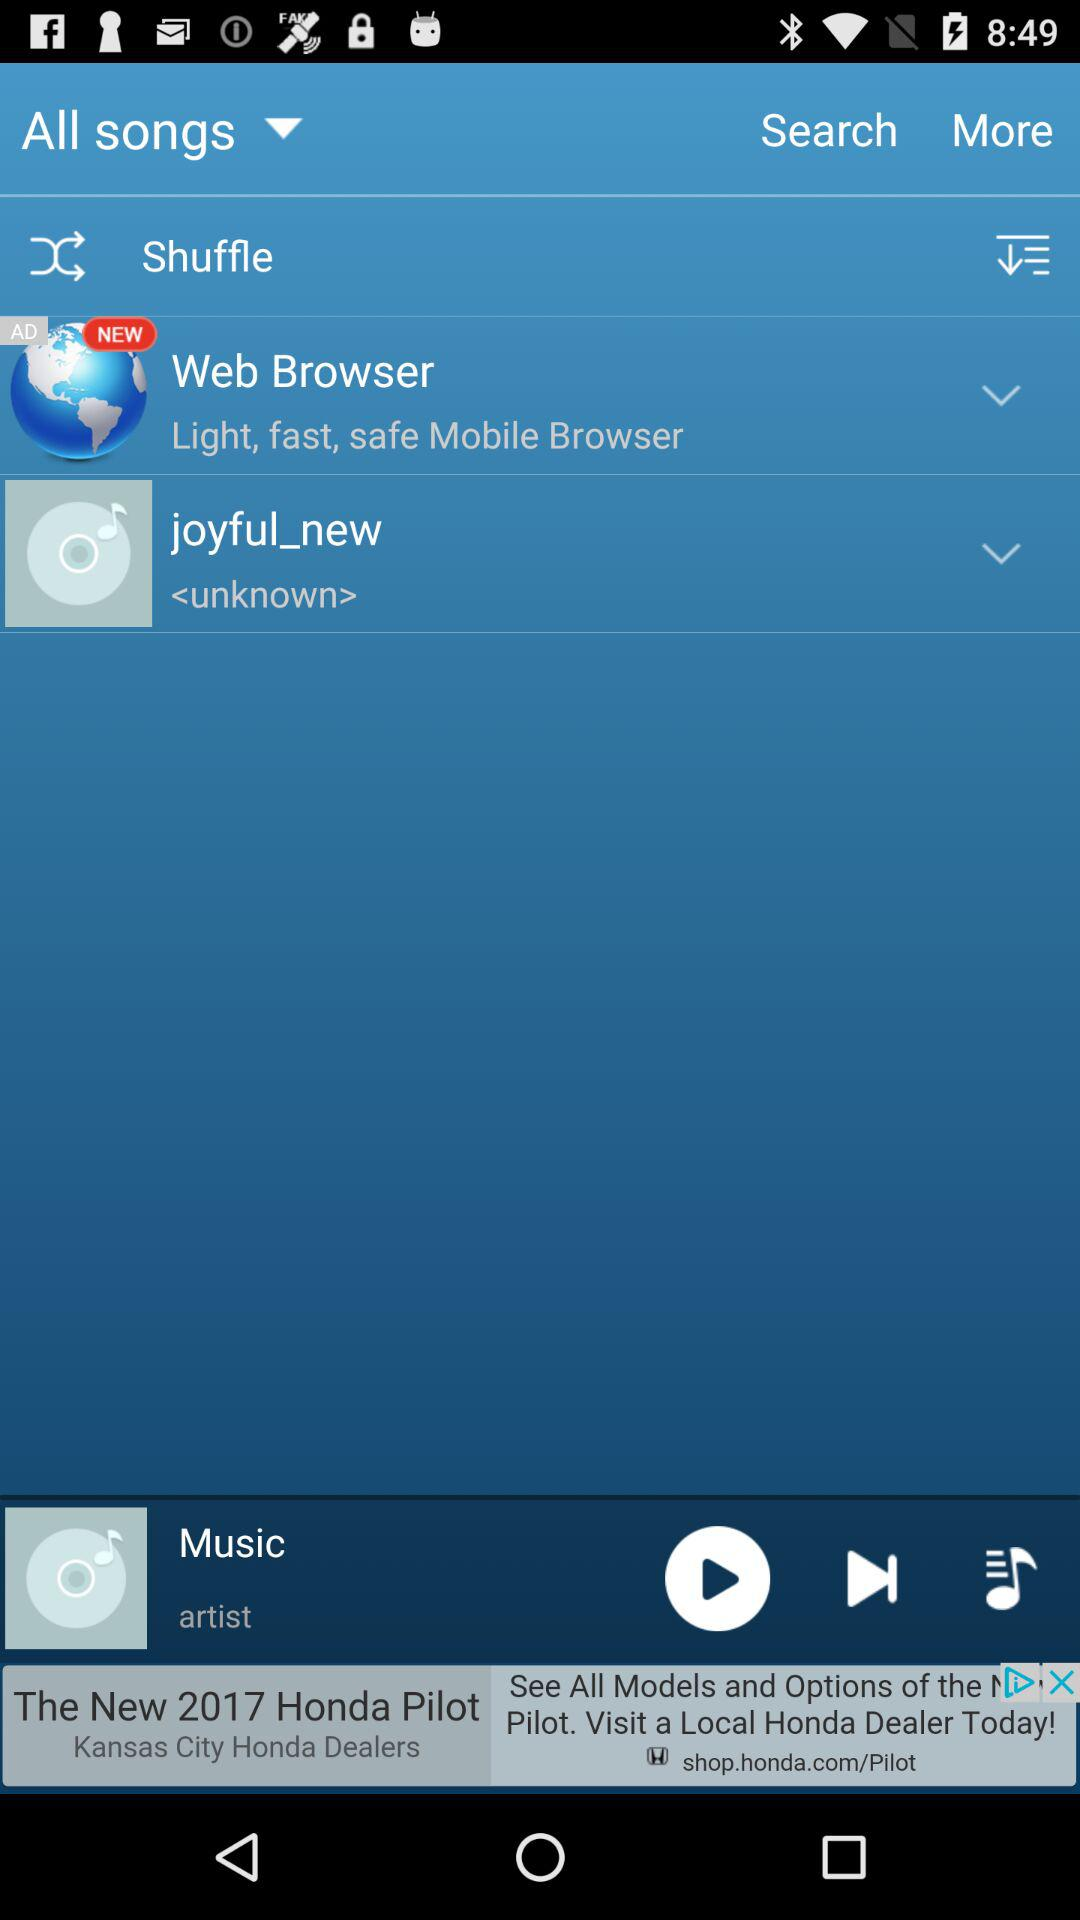What is the name of the song in the song list? The name of the song is "joyful_new". 